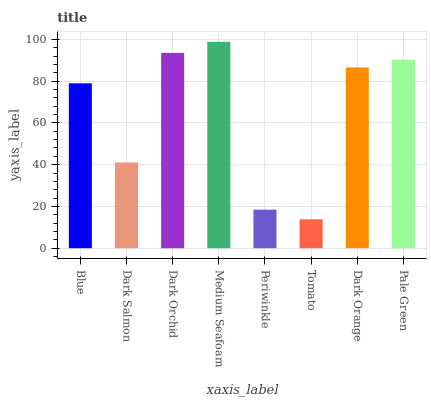Is Tomato the minimum?
Answer yes or no. Yes. Is Medium Seafoam the maximum?
Answer yes or no. Yes. Is Dark Salmon the minimum?
Answer yes or no. No. Is Dark Salmon the maximum?
Answer yes or no. No. Is Blue greater than Dark Salmon?
Answer yes or no. Yes. Is Dark Salmon less than Blue?
Answer yes or no. Yes. Is Dark Salmon greater than Blue?
Answer yes or no. No. Is Blue less than Dark Salmon?
Answer yes or no. No. Is Dark Orange the high median?
Answer yes or no. Yes. Is Blue the low median?
Answer yes or no. Yes. Is Pale Green the high median?
Answer yes or no. No. Is Pale Green the low median?
Answer yes or no. No. 